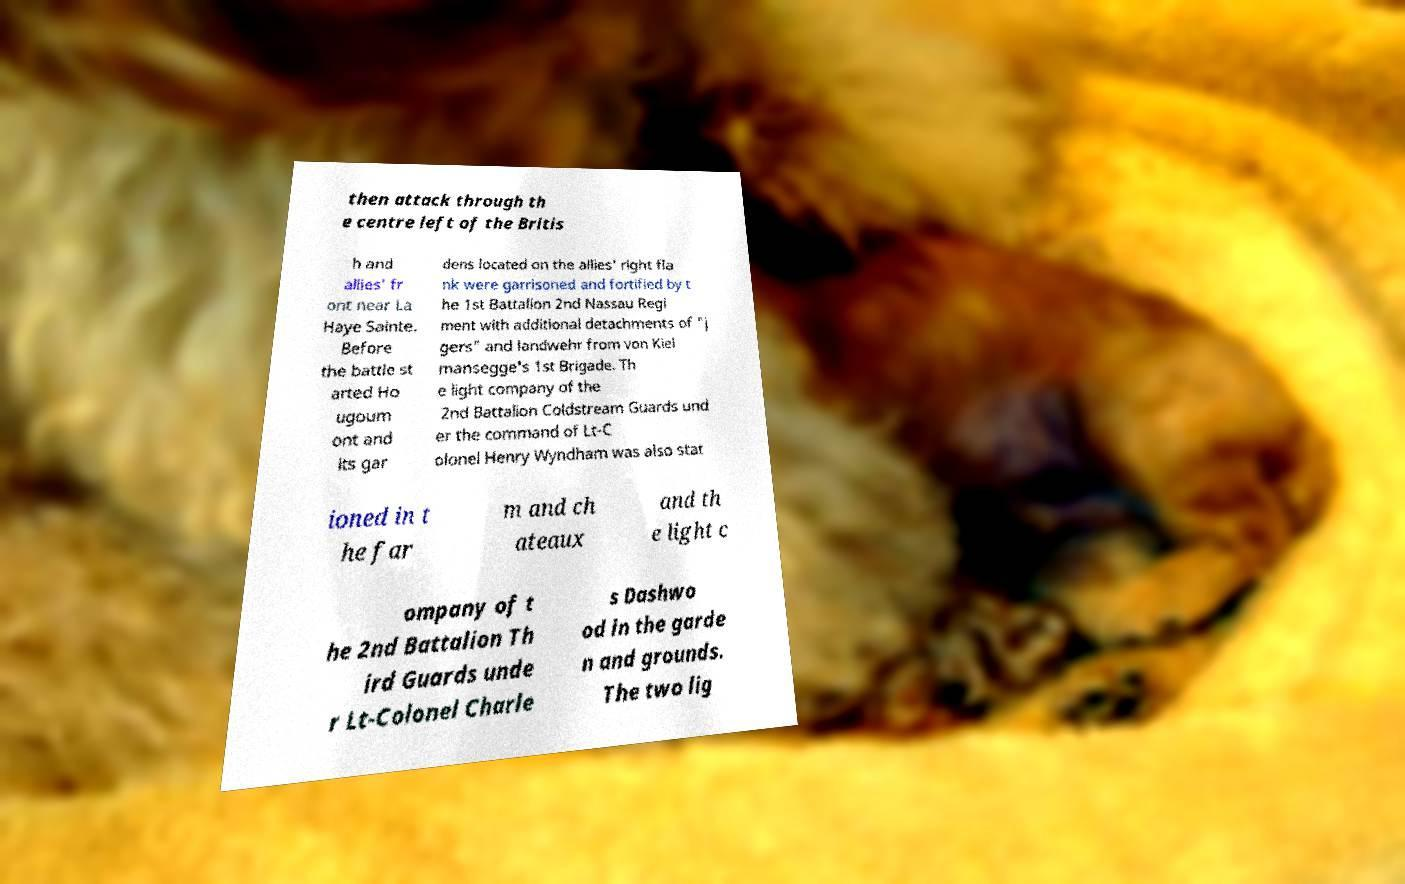Please read and relay the text visible in this image. What does it say? then attack through th e centre left of the Britis h and allies' fr ont near La Haye Sainte. Before the battle st arted Ho ugoum ont and its gar dens located on the allies' right fla nk were garrisoned and fortified by t he 1st Battalion 2nd Nassau Regi ment with additional detachments of "j gers" and landwehr from von Kiel mansegge's 1st Brigade. Th e light company of the 2nd Battalion Coldstream Guards und er the command of Lt-C olonel Henry Wyndham was also stat ioned in t he far m and ch ateaux and th e light c ompany of t he 2nd Battalion Th ird Guards unde r Lt-Colonel Charle s Dashwo od in the garde n and grounds. The two lig 